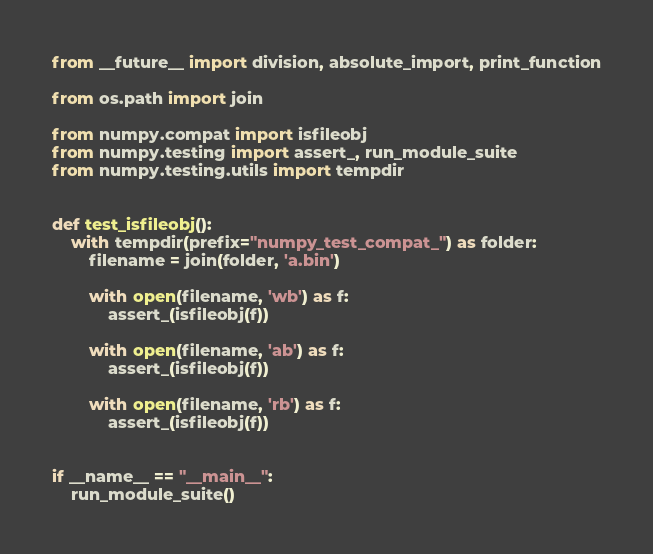Convert code to text. <code><loc_0><loc_0><loc_500><loc_500><_Python_>from __future__ import division, absolute_import, print_function

from os.path import join

from numpy.compat import isfileobj
from numpy.testing import assert_, run_module_suite
from numpy.testing.utils import tempdir


def test_isfileobj():
    with tempdir(prefix="numpy_test_compat_") as folder:
        filename = join(folder, 'a.bin')

        with open(filename, 'wb') as f:
            assert_(isfileobj(f))

        with open(filename, 'ab') as f:
            assert_(isfileobj(f))

        with open(filename, 'rb') as f:
            assert_(isfileobj(f))


if __name__ == "__main__":
    run_module_suite()
</code> 